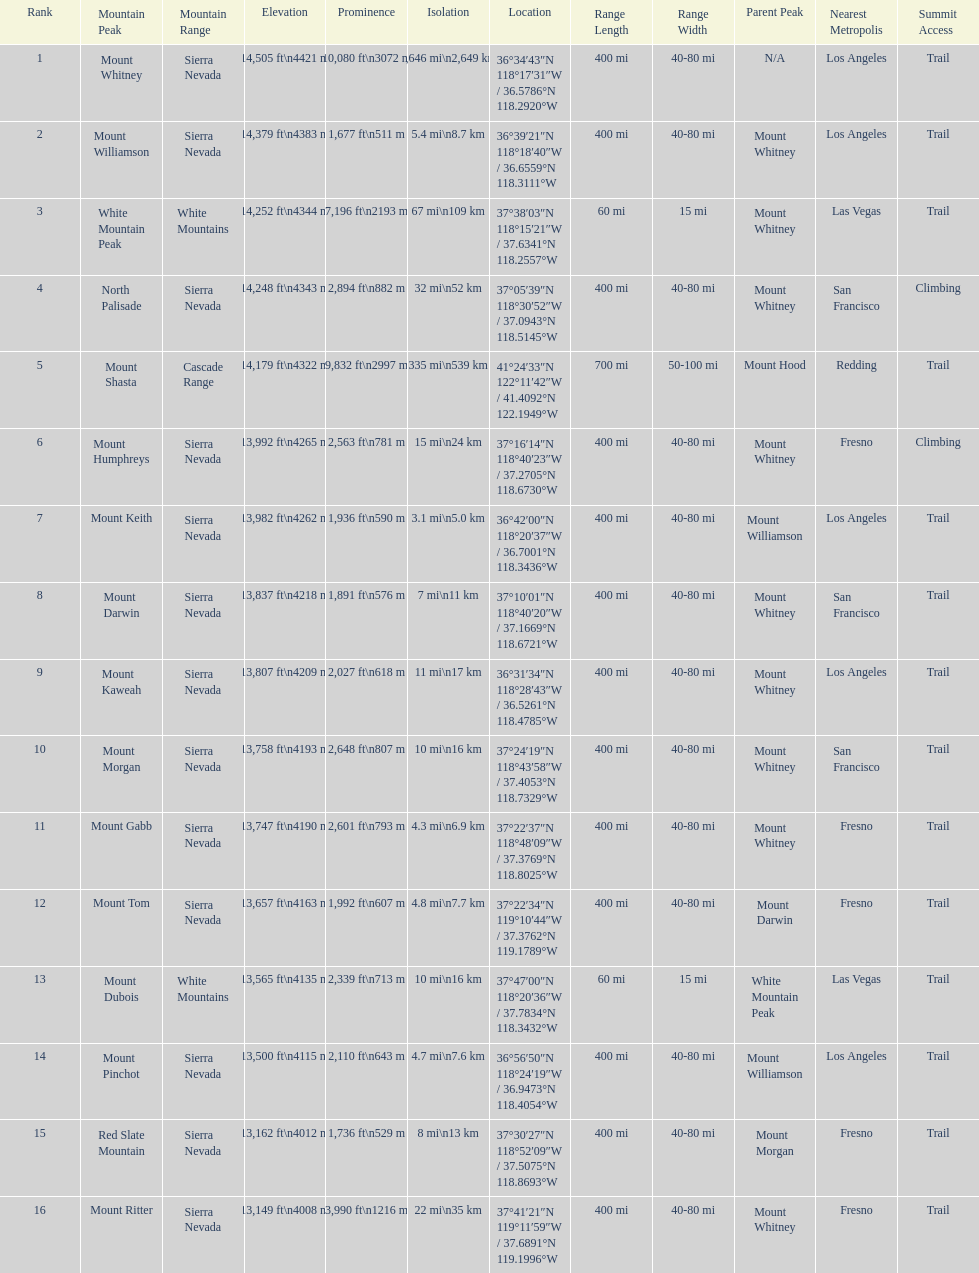What is the tallest peak in the sierra nevadas? Mount Whitney. 